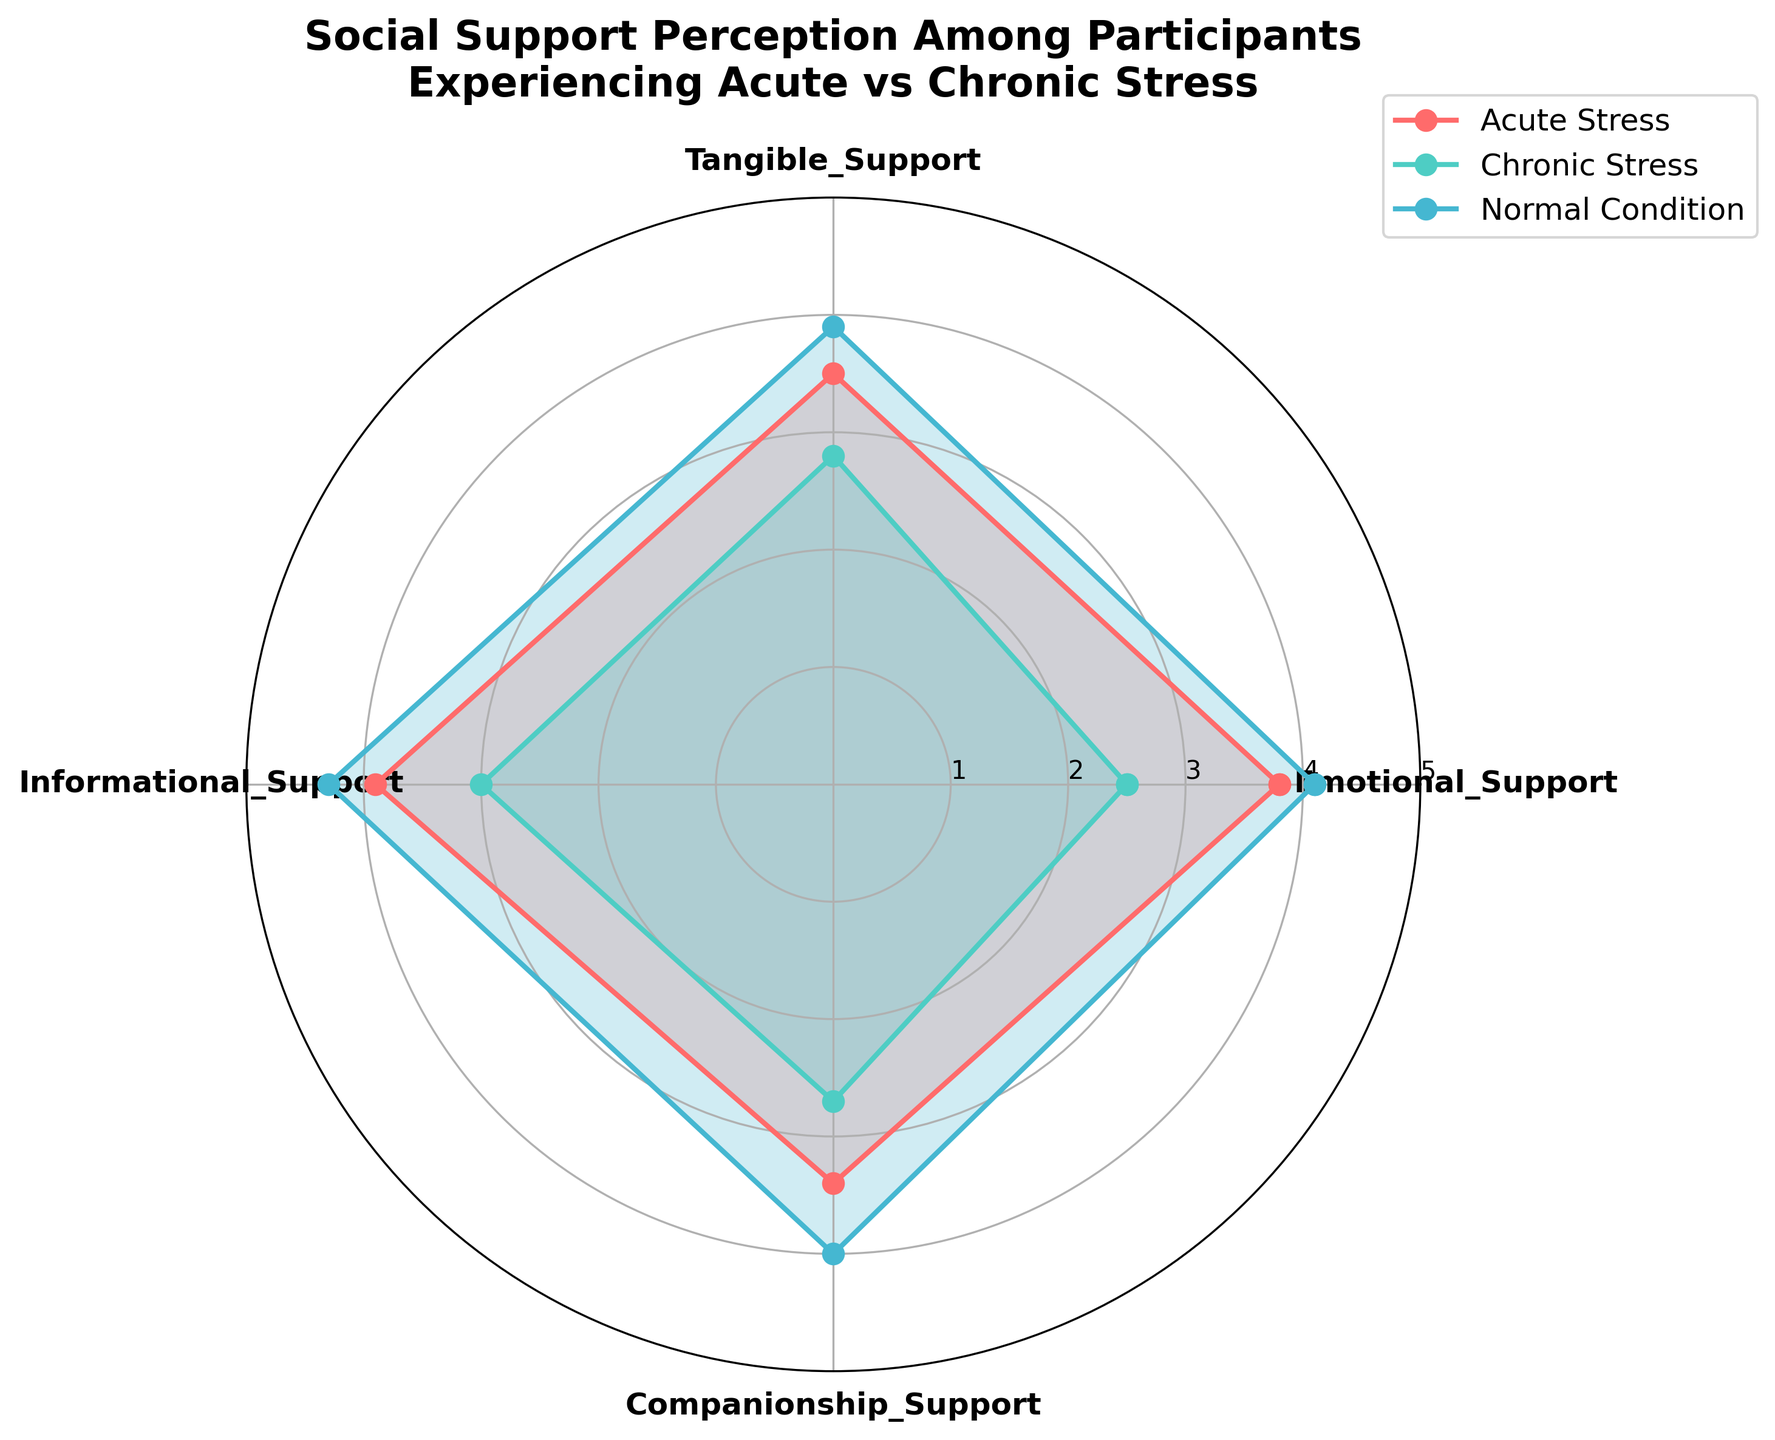What is the title of the figure? The title is located at the top of the chart and provides a clear description of the chart’s subject. It states "Social Support Perception Among Participants Experiencing Acute vs Chronic Stress".
Answer: Social Support Perception Among Participants Experiencing Acute vs Chronic Stress How many types of social support are shown in the chart? There are four different categories of social support types shown around the radar chart. These are Emotional Support, Tangible Support, Informational Support, and Companionship Support.
Answer: Four Which condition shows the highest level of emotional support? To compare the levels of emotional support among different conditions, look at the values for Emotional Support in the chart. The highest value in this segment is for Normal Condition.
Answer: Normal Condition What is the average of the Chronic Stress values for all types of support? Add up all the values for Chronic Stress (2.5 + 2.8 + 3.0 + 2.7) and divide by the number of categories (4). (2.5 + 2.8 + 3.0 + 2.7) / 4 = 11 / 4 = 2.75
Answer: 2.75 Which type of support shows the smallest difference between Acute Stress and Chronic Stress? Compare the differences between Acute and Chronic Stress for each support type: Emotional (3.8 - 2.5 = 1.3), Tangible (3.5 - 2.8 = 0.7), Informational (3.9 - 3.0 = 0.9), Companionship (3.4 - 2.7 = 0.7). The smallest differences are in Tangible and Companionship Support (both 0.7).
Answer: Tangible Support and Companionship Support Which type of support has the most noticeable decline under Chronic Stress compared to Normal Condition? Compare the values for each type of support under Normal Condition and Chronic Stress, and calculate the decline: Emotional (4.1 - 2.5 = 1.6), Tangible (3.9 - 2.8 = 1.1), Informational (4.3 - 3.0 = 1.3), Companionship (4.0 - 2.7 = 1.3). The greatest decline is seen in Emotional Support (1.6).
Answer: Emotional Support Is the level of Informational Support higher for Acute Stress or Chronic Stress? Compare the values of Informational Support for Acute Stress (3.9) and Chronic Stress (3.0). The level under Acute Stress is higher.
Answer: Acute Stress How does Companionship Support compare across the three conditions? Compare the values for Companionship Support under all three conditions: Acute Stress (3.4), Chronic Stress (2.7), and Normal Condition (4.0). The values show Normal Condition is the highest, followed by Acute Stress, and then Chronic Stress.
Answer: Normal Condition > Acute Stress > Chronic Stress What is the sum of all values for Normal Condition? Add up all the values for Normal Condition across all types of support: 4.1 + 3.9 + 4.3 + 4.0 = 16.3.
Answer: 16.3 